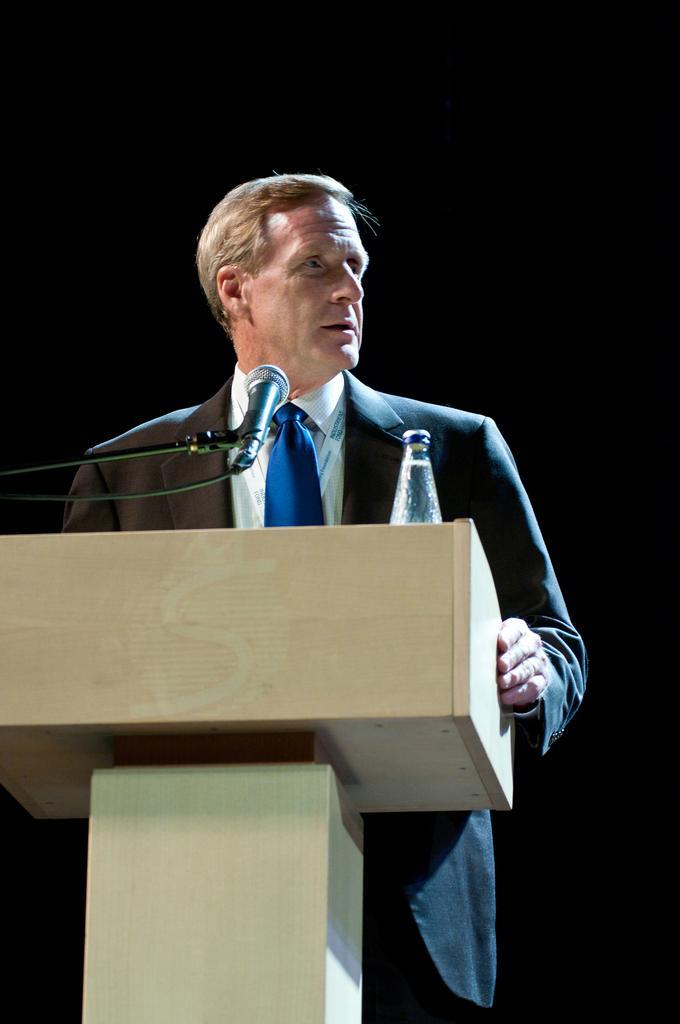Can you describe this image briefly? In this image I can see a person wearing white shirt, blue tie and black blazer is standing in front of the podium which is cream in color and I can see a microphone and a water bottle on the podium. I can see the black colored background. 